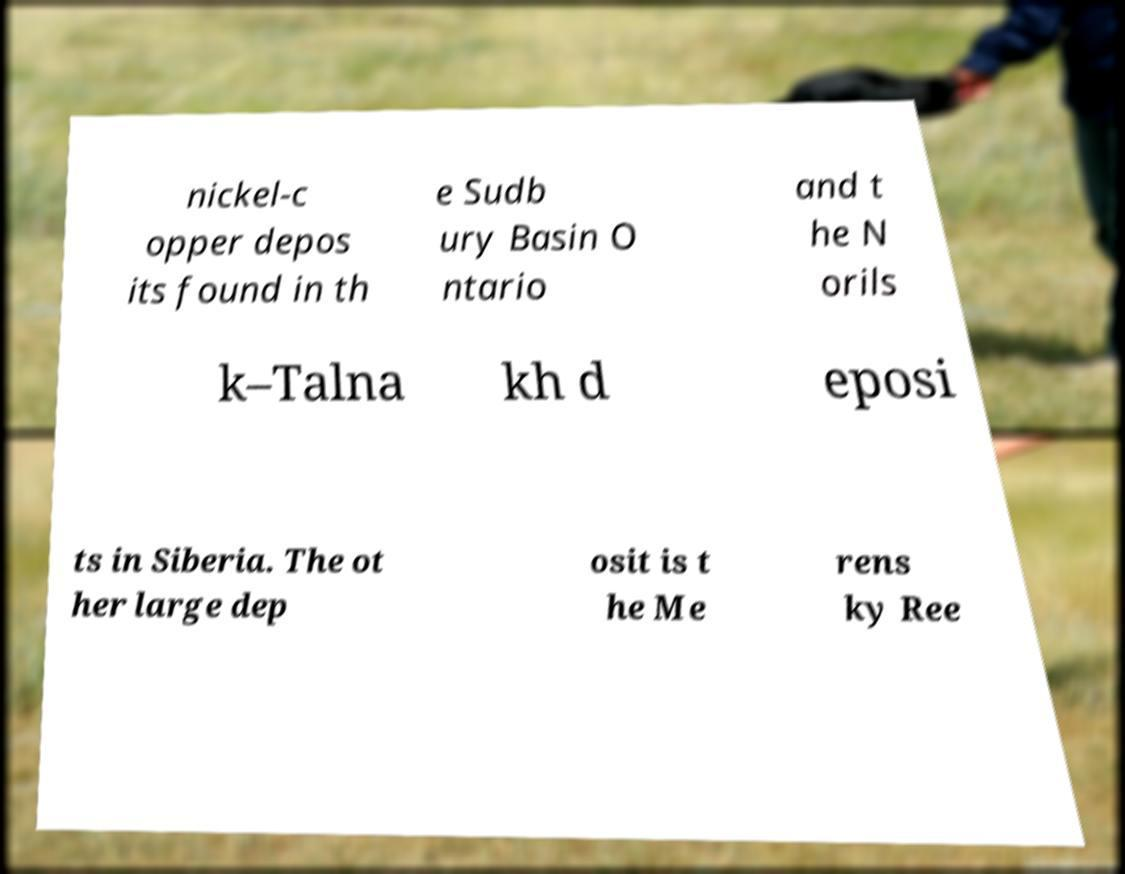I need the written content from this picture converted into text. Can you do that? nickel-c opper depos its found in th e Sudb ury Basin O ntario and t he N orils k–Talna kh d eposi ts in Siberia. The ot her large dep osit is t he Me rens ky Ree 